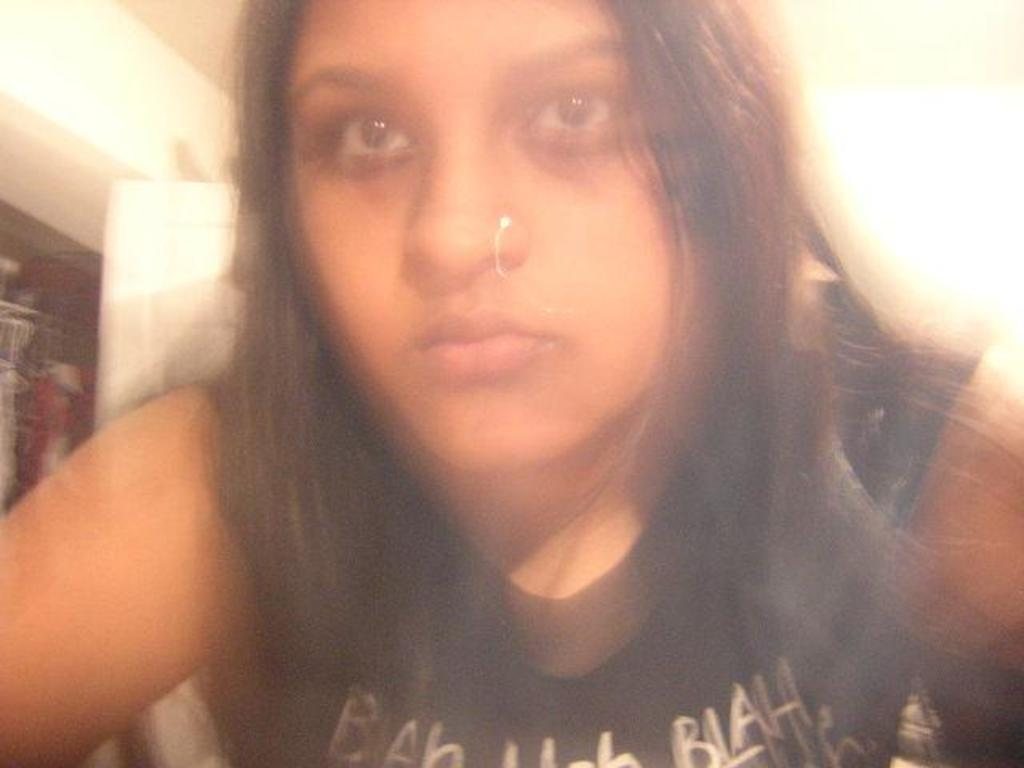Who is the main subject in the image? There is a woman in the image. What is the woman wearing? The woman is wearing clothes. Can you describe any accessories the woman is wearing? The woman has a nose stud. What is the appearance of the background in the image? The background of the image is blurred. What type of shop can be seen in the background of the image? There is no shop visible in the background of the image; the background is blurred. How many fingers does the woman have on her right hand in the image? The number of fingers on the woman's right hand cannot be determined from the image, as her hand is not visible. 